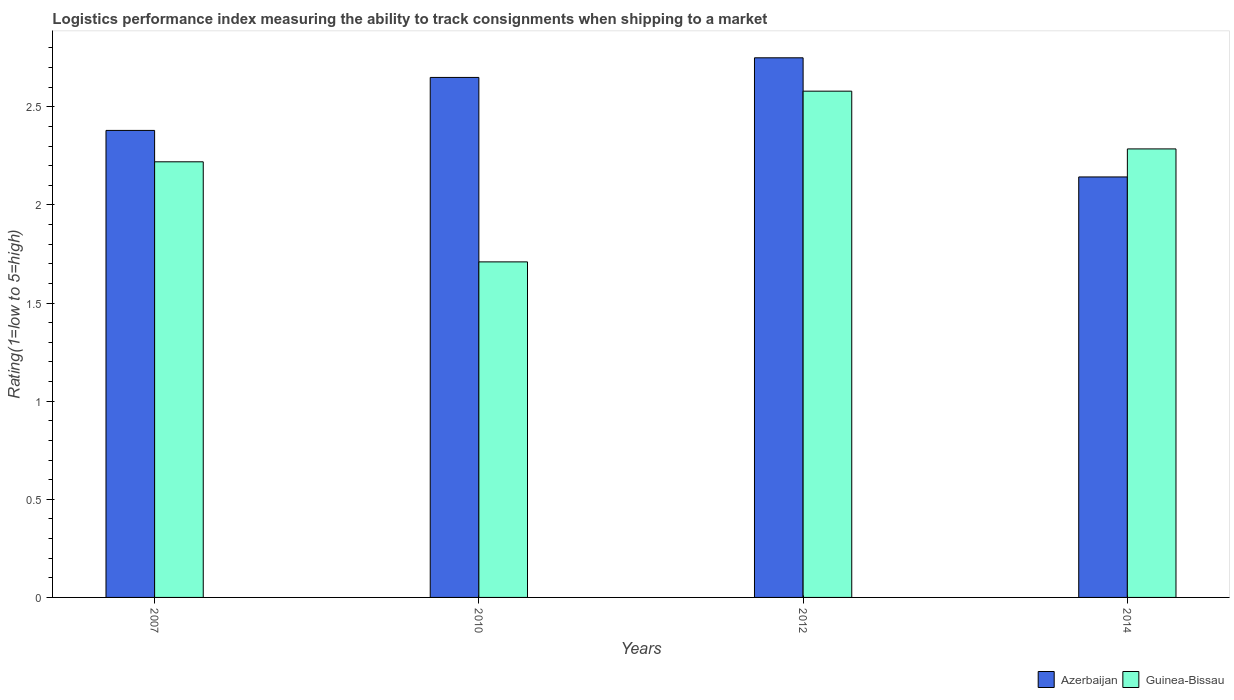How many groups of bars are there?
Give a very brief answer. 4. Are the number of bars on each tick of the X-axis equal?
Keep it short and to the point. Yes. How many bars are there on the 3rd tick from the left?
Your answer should be compact. 2. How many bars are there on the 1st tick from the right?
Your answer should be very brief. 2. What is the label of the 2nd group of bars from the left?
Keep it short and to the point. 2010. In how many cases, is the number of bars for a given year not equal to the number of legend labels?
Offer a terse response. 0. What is the Logistic performance index in Azerbaijan in 2012?
Your response must be concise. 2.75. Across all years, what is the maximum Logistic performance index in Guinea-Bissau?
Ensure brevity in your answer.  2.58. Across all years, what is the minimum Logistic performance index in Guinea-Bissau?
Your answer should be very brief. 1.71. In which year was the Logistic performance index in Guinea-Bissau maximum?
Offer a terse response. 2012. What is the total Logistic performance index in Azerbaijan in the graph?
Offer a terse response. 9.92. What is the difference between the Logistic performance index in Azerbaijan in 2010 and that in 2014?
Provide a short and direct response. 0.51. What is the difference between the Logistic performance index in Guinea-Bissau in 2014 and the Logistic performance index in Azerbaijan in 2012?
Make the answer very short. -0.46. What is the average Logistic performance index in Azerbaijan per year?
Offer a terse response. 2.48. In the year 2007, what is the difference between the Logistic performance index in Guinea-Bissau and Logistic performance index in Azerbaijan?
Keep it short and to the point. -0.16. In how many years, is the Logistic performance index in Azerbaijan greater than 2?
Ensure brevity in your answer.  4. What is the ratio of the Logistic performance index in Azerbaijan in 2007 to that in 2012?
Keep it short and to the point. 0.87. What is the difference between the highest and the second highest Logistic performance index in Azerbaijan?
Provide a short and direct response. 0.1. What is the difference between the highest and the lowest Logistic performance index in Guinea-Bissau?
Provide a short and direct response. 0.87. What does the 1st bar from the left in 2012 represents?
Your answer should be compact. Azerbaijan. What does the 1st bar from the right in 2010 represents?
Make the answer very short. Guinea-Bissau. How many bars are there?
Your answer should be compact. 8. How many years are there in the graph?
Provide a short and direct response. 4. What is the difference between two consecutive major ticks on the Y-axis?
Give a very brief answer. 0.5. Are the values on the major ticks of Y-axis written in scientific E-notation?
Ensure brevity in your answer.  No. Does the graph contain any zero values?
Ensure brevity in your answer.  No. Where does the legend appear in the graph?
Offer a very short reply. Bottom right. How are the legend labels stacked?
Your answer should be compact. Horizontal. What is the title of the graph?
Offer a terse response. Logistics performance index measuring the ability to track consignments when shipping to a market. Does "Tanzania" appear as one of the legend labels in the graph?
Give a very brief answer. No. What is the label or title of the Y-axis?
Provide a succinct answer. Rating(1=low to 5=high). What is the Rating(1=low to 5=high) in Azerbaijan in 2007?
Your answer should be compact. 2.38. What is the Rating(1=low to 5=high) in Guinea-Bissau in 2007?
Keep it short and to the point. 2.22. What is the Rating(1=low to 5=high) in Azerbaijan in 2010?
Your answer should be very brief. 2.65. What is the Rating(1=low to 5=high) of Guinea-Bissau in 2010?
Keep it short and to the point. 1.71. What is the Rating(1=low to 5=high) in Azerbaijan in 2012?
Give a very brief answer. 2.75. What is the Rating(1=low to 5=high) of Guinea-Bissau in 2012?
Offer a terse response. 2.58. What is the Rating(1=low to 5=high) in Azerbaijan in 2014?
Keep it short and to the point. 2.14. What is the Rating(1=low to 5=high) in Guinea-Bissau in 2014?
Provide a short and direct response. 2.29. Across all years, what is the maximum Rating(1=low to 5=high) in Azerbaijan?
Give a very brief answer. 2.75. Across all years, what is the maximum Rating(1=low to 5=high) of Guinea-Bissau?
Your answer should be compact. 2.58. Across all years, what is the minimum Rating(1=low to 5=high) in Azerbaijan?
Your answer should be compact. 2.14. Across all years, what is the minimum Rating(1=low to 5=high) in Guinea-Bissau?
Provide a short and direct response. 1.71. What is the total Rating(1=low to 5=high) in Azerbaijan in the graph?
Your answer should be very brief. 9.92. What is the total Rating(1=low to 5=high) in Guinea-Bissau in the graph?
Provide a succinct answer. 8.8. What is the difference between the Rating(1=low to 5=high) of Azerbaijan in 2007 and that in 2010?
Make the answer very short. -0.27. What is the difference between the Rating(1=low to 5=high) of Guinea-Bissau in 2007 and that in 2010?
Offer a terse response. 0.51. What is the difference between the Rating(1=low to 5=high) of Azerbaijan in 2007 and that in 2012?
Your answer should be compact. -0.37. What is the difference between the Rating(1=low to 5=high) in Guinea-Bissau in 2007 and that in 2012?
Keep it short and to the point. -0.36. What is the difference between the Rating(1=low to 5=high) of Azerbaijan in 2007 and that in 2014?
Provide a short and direct response. 0.24. What is the difference between the Rating(1=low to 5=high) of Guinea-Bissau in 2007 and that in 2014?
Make the answer very short. -0.07. What is the difference between the Rating(1=low to 5=high) of Azerbaijan in 2010 and that in 2012?
Provide a succinct answer. -0.1. What is the difference between the Rating(1=low to 5=high) of Guinea-Bissau in 2010 and that in 2012?
Your answer should be very brief. -0.87. What is the difference between the Rating(1=low to 5=high) in Azerbaijan in 2010 and that in 2014?
Offer a very short reply. 0.51. What is the difference between the Rating(1=low to 5=high) of Guinea-Bissau in 2010 and that in 2014?
Offer a terse response. -0.58. What is the difference between the Rating(1=low to 5=high) of Azerbaijan in 2012 and that in 2014?
Make the answer very short. 0.61. What is the difference between the Rating(1=low to 5=high) in Guinea-Bissau in 2012 and that in 2014?
Keep it short and to the point. 0.29. What is the difference between the Rating(1=low to 5=high) of Azerbaijan in 2007 and the Rating(1=low to 5=high) of Guinea-Bissau in 2010?
Your answer should be compact. 0.67. What is the difference between the Rating(1=low to 5=high) of Azerbaijan in 2007 and the Rating(1=low to 5=high) of Guinea-Bissau in 2012?
Provide a short and direct response. -0.2. What is the difference between the Rating(1=low to 5=high) in Azerbaijan in 2007 and the Rating(1=low to 5=high) in Guinea-Bissau in 2014?
Provide a short and direct response. 0.09. What is the difference between the Rating(1=low to 5=high) in Azerbaijan in 2010 and the Rating(1=low to 5=high) in Guinea-Bissau in 2012?
Offer a terse response. 0.07. What is the difference between the Rating(1=low to 5=high) in Azerbaijan in 2010 and the Rating(1=low to 5=high) in Guinea-Bissau in 2014?
Provide a short and direct response. 0.36. What is the difference between the Rating(1=low to 5=high) in Azerbaijan in 2012 and the Rating(1=low to 5=high) in Guinea-Bissau in 2014?
Your answer should be very brief. 0.46. What is the average Rating(1=low to 5=high) in Azerbaijan per year?
Your answer should be compact. 2.48. What is the average Rating(1=low to 5=high) of Guinea-Bissau per year?
Make the answer very short. 2.2. In the year 2007, what is the difference between the Rating(1=low to 5=high) of Azerbaijan and Rating(1=low to 5=high) of Guinea-Bissau?
Provide a succinct answer. 0.16. In the year 2010, what is the difference between the Rating(1=low to 5=high) in Azerbaijan and Rating(1=low to 5=high) in Guinea-Bissau?
Your response must be concise. 0.94. In the year 2012, what is the difference between the Rating(1=low to 5=high) in Azerbaijan and Rating(1=low to 5=high) in Guinea-Bissau?
Make the answer very short. 0.17. In the year 2014, what is the difference between the Rating(1=low to 5=high) in Azerbaijan and Rating(1=low to 5=high) in Guinea-Bissau?
Ensure brevity in your answer.  -0.14. What is the ratio of the Rating(1=low to 5=high) in Azerbaijan in 2007 to that in 2010?
Offer a terse response. 0.9. What is the ratio of the Rating(1=low to 5=high) of Guinea-Bissau in 2007 to that in 2010?
Your response must be concise. 1.3. What is the ratio of the Rating(1=low to 5=high) in Azerbaijan in 2007 to that in 2012?
Your answer should be compact. 0.87. What is the ratio of the Rating(1=low to 5=high) in Guinea-Bissau in 2007 to that in 2012?
Make the answer very short. 0.86. What is the ratio of the Rating(1=low to 5=high) in Azerbaijan in 2007 to that in 2014?
Your answer should be very brief. 1.11. What is the ratio of the Rating(1=low to 5=high) in Guinea-Bissau in 2007 to that in 2014?
Provide a succinct answer. 0.97. What is the ratio of the Rating(1=low to 5=high) in Azerbaijan in 2010 to that in 2012?
Offer a very short reply. 0.96. What is the ratio of the Rating(1=low to 5=high) of Guinea-Bissau in 2010 to that in 2012?
Your response must be concise. 0.66. What is the ratio of the Rating(1=low to 5=high) of Azerbaijan in 2010 to that in 2014?
Provide a short and direct response. 1.24. What is the ratio of the Rating(1=low to 5=high) of Guinea-Bissau in 2010 to that in 2014?
Make the answer very short. 0.75. What is the ratio of the Rating(1=low to 5=high) of Azerbaijan in 2012 to that in 2014?
Keep it short and to the point. 1.28. What is the ratio of the Rating(1=low to 5=high) of Guinea-Bissau in 2012 to that in 2014?
Your response must be concise. 1.13. What is the difference between the highest and the second highest Rating(1=low to 5=high) in Guinea-Bissau?
Provide a succinct answer. 0.29. What is the difference between the highest and the lowest Rating(1=low to 5=high) in Azerbaijan?
Offer a very short reply. 0.61. What is the difference between the highest and the lowest Rating(1=low to 5=high) of Guinea-Bissau?
Ensure brevity in your answer.  0.87. 